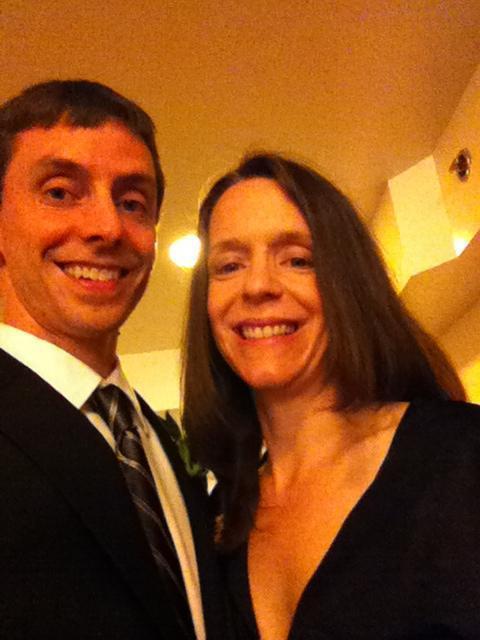How many people are there?
Give a very brief answer. 2. 